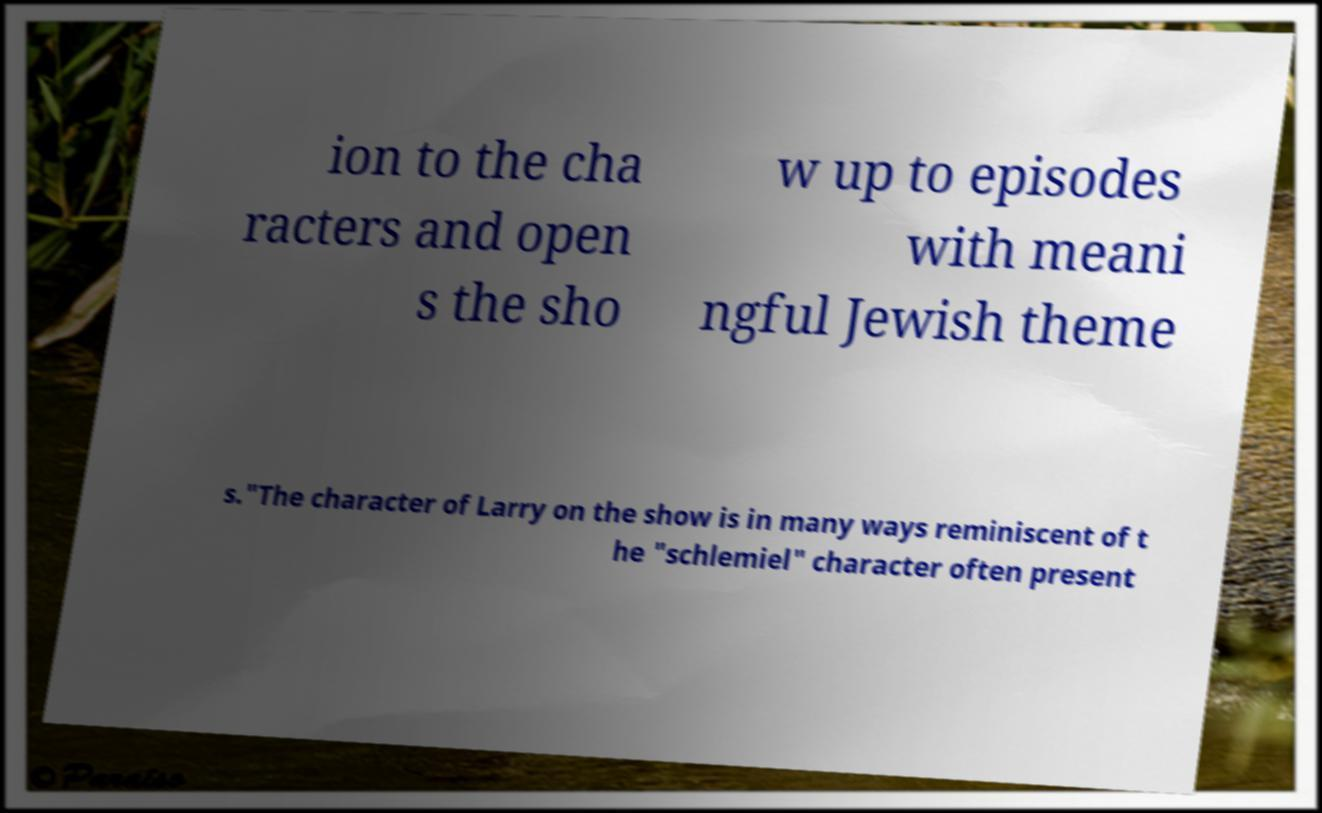What messages or text are displayed in this image? I need them in a readable, typed format. ion to the cha racters and open s the sho w up to episodes with meani ngful Jewish theme s."The character of Larry on the show is in many ways reminiscent of t he "schlemiel" character often present 